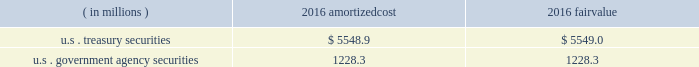Each clearing firm is required to deposit and maintain balances in the form of cash , u.s .
Government securities , certain foreign government securities , bank letters of credit or other approved investments to satisfy performance bond and guaranty fund requirements .
All non-cash deposits are marked-to-market and haircut on a daily basis .
Securities deposited by the clearing firms are not reflected in the consolidated financial statements and the clearing house does not earn any interest on these deposits .
These balances may fluctuate significantly over time due to investment choices available to clearing firms and changes in the amount of contributions required .
In addition , the rules and regulations of cbot require that collateral be provided for delivery of physical commodities , maintenance of capital requirements and deposits on pending arbitration matters .
To satisfy these requirements , clearing firms that have accounts that trade certain cbot products have deposited cash , u.s .
Treasury securities or letters of credit .
The clearing house marks-to-market open positions at least once a day ( twice a day for futures and options contracts ) , and require payment from clearing firms whose positions have lost value and make payments to clearing firms whose positions have gained value .
The clearing house has the capability to mark-to-market more frequently as market conditions warrant .
Under the extremely unlikely scenario of simultaneous default by every clearing firm who has open positions with unrealized losses , the maximum exposure related to positions other than credit default and interest rate swap contracts would be one half day of changes in fair value of all open positions , before considering the clearing houses 2019 ability to access defaulting clearing firms 2019 collateral deposits .
For cleared credit default swap and interest rate swap contracts , the maximum exposure related to cme 2019s guarantee would be one full day of changes in fair value of all open positions , before considering cme 2019s ability to access defaulting clearing firms 2019 collateral .
During 2017 , the clearing house transferred an average of approximately $ 2.4 billion a day through the clearing system for settlement from clearing firms whose positions had lost value to clearing firms whose positions had gained value .
The clearing house reduces the guarantee exposure through initial and maintenance performance bond requirements and mandatory guaranty fund contributions .
The company believes that the guarantee liability is immaterial and therefore has not recorded any liability at december 31 , 2017 .
At december 31 , 2016 , performance bond and guaranty fund contribution assets on the consolidated balance sheets included cash as well as u.s .
Treasury and u.s .
Government agency securities with maturity dates of 90 days or less .
The u.s .
Treasury and u.s .
Government agency securities were purchased by cme , at its discretion , using cash collateral .
The benefits , including interest earned , and risks of ownership accrue to cme .
Interest earned is included in investment income on the consolidated statements of income .
There were no u.s .
Treasury and u.s .
Government agency securities held at december 31 , 2017 .
The amortized cost and fair value of these securities at december 31 , 2016 were as follows : ( in millions ) amortized .
Cme has been designated as a systemically important financial market utility by the financial stability oversight council and maintains a cash account at the federal reserve bank of chicago .
At december 31 , 2017 and december 31 , 2016 , cme maintained $ 34.2 billion and $ 6.2 billion , respectively , within the cash account at the federal reserve bank of chicago .
Clearing firms , at their option , may instruct cme to deposit the cash held by cme into one of the ief programs .
The total principal in the ief programs was $ 1.1 billion at december 31 , 2017 and $ 6.8 billion at december 31 .
What was the ratio of the cme cash account at the federal reserve bank of chicago in 2017 compared to 2016? 
Computations: (34.2 / 6.2)
Answer: 5.51613. 